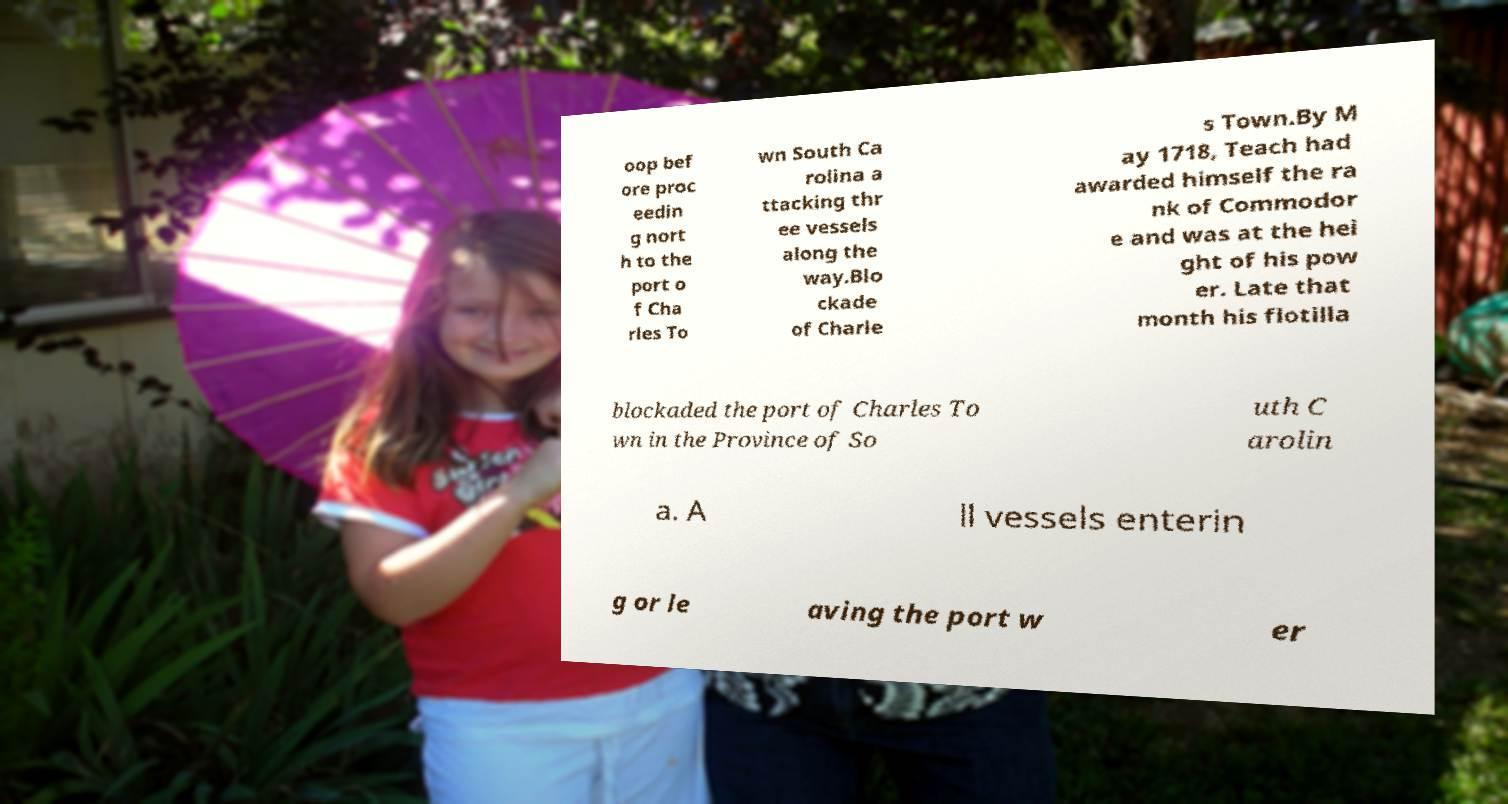Please identify and transcribe the text found in this image. oop bef ore proc eedin g nort h to the port o f Cha rles To wn South Ca rolina a ttacking thr ee vessels along the way.Blo ckade of Charle s Town.By M ay 1718, Teach had awarded himself the ra nk of Commodor e and was at the hei ght of his pow er. Late that month his flotilla blockaded the port of Charles To wn in the Province of So uth C arolin a. A ll vessels enterin g or le aving the port w er 